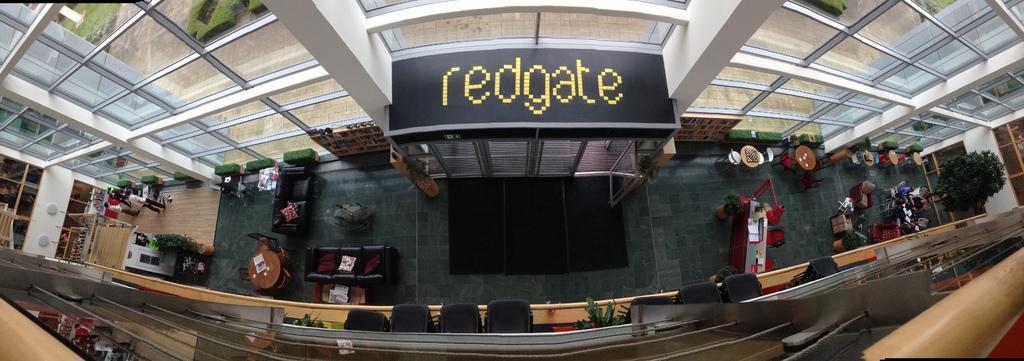How would you summarize this image in a sentence or two? In this image I can see the inner part of the building. To the left I can see the couch, table, chairs and few people standing. To the right I can see the flower pots, tree, tables, chairs and I can see few are sitting on the chairs. To the side of these people there is a glass wall and I can see the name red-gate is written on the building. I can also see the railing in the front. 